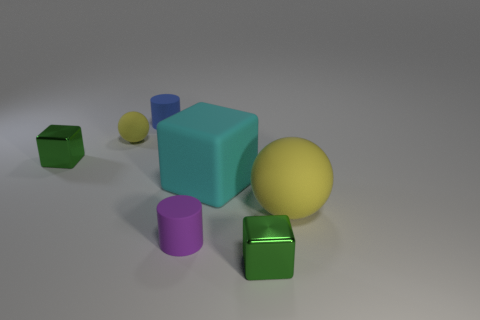Do the tiny block behind the big cyan block and the big ball have the same material?
Give a very brief answer. No. How big is the yellow thing to the right of the small metallic block that is in front of the tiny green shiny cube behind the tiny purple cylinder?
Offer a terse response. Large. How many other objects are there of the same color as the big matte cube?
Keep it short and to the point. 0. The blue matte object that is the same size as the purple cylinder is what shape?
Your answer should be very brief. Cylinder. How big is the green cube that is left of the small blue cylinder?
Offer a terse response. Small. Is the color of the rubber ball that is in front of the tiny yellow matte thing the same as the cube to the left of the blue object?
Your answer should be compact. No. The sphere that is behind the tiny shiny object that is behind the tiny green metallic block that is to the right of the small blue rubber cylinder is made of what material?
Make the answer very short. Rubber. Is there a red matte ball of the same size as the blue rubber cylinder?
Ensure brevity in your answer.  No. What is the material of the yellow thing that is the same size as the cyan block?
Offer a terse response. Rubber. What is the shape of the yellow thing that is to the left of the large rubber ball?
Your answer should be very brief. Sphere. 